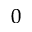Convert formula to latex. <formula><loc_0><loc_0><loc_500><loc_500>_ { 0 }</formula> 